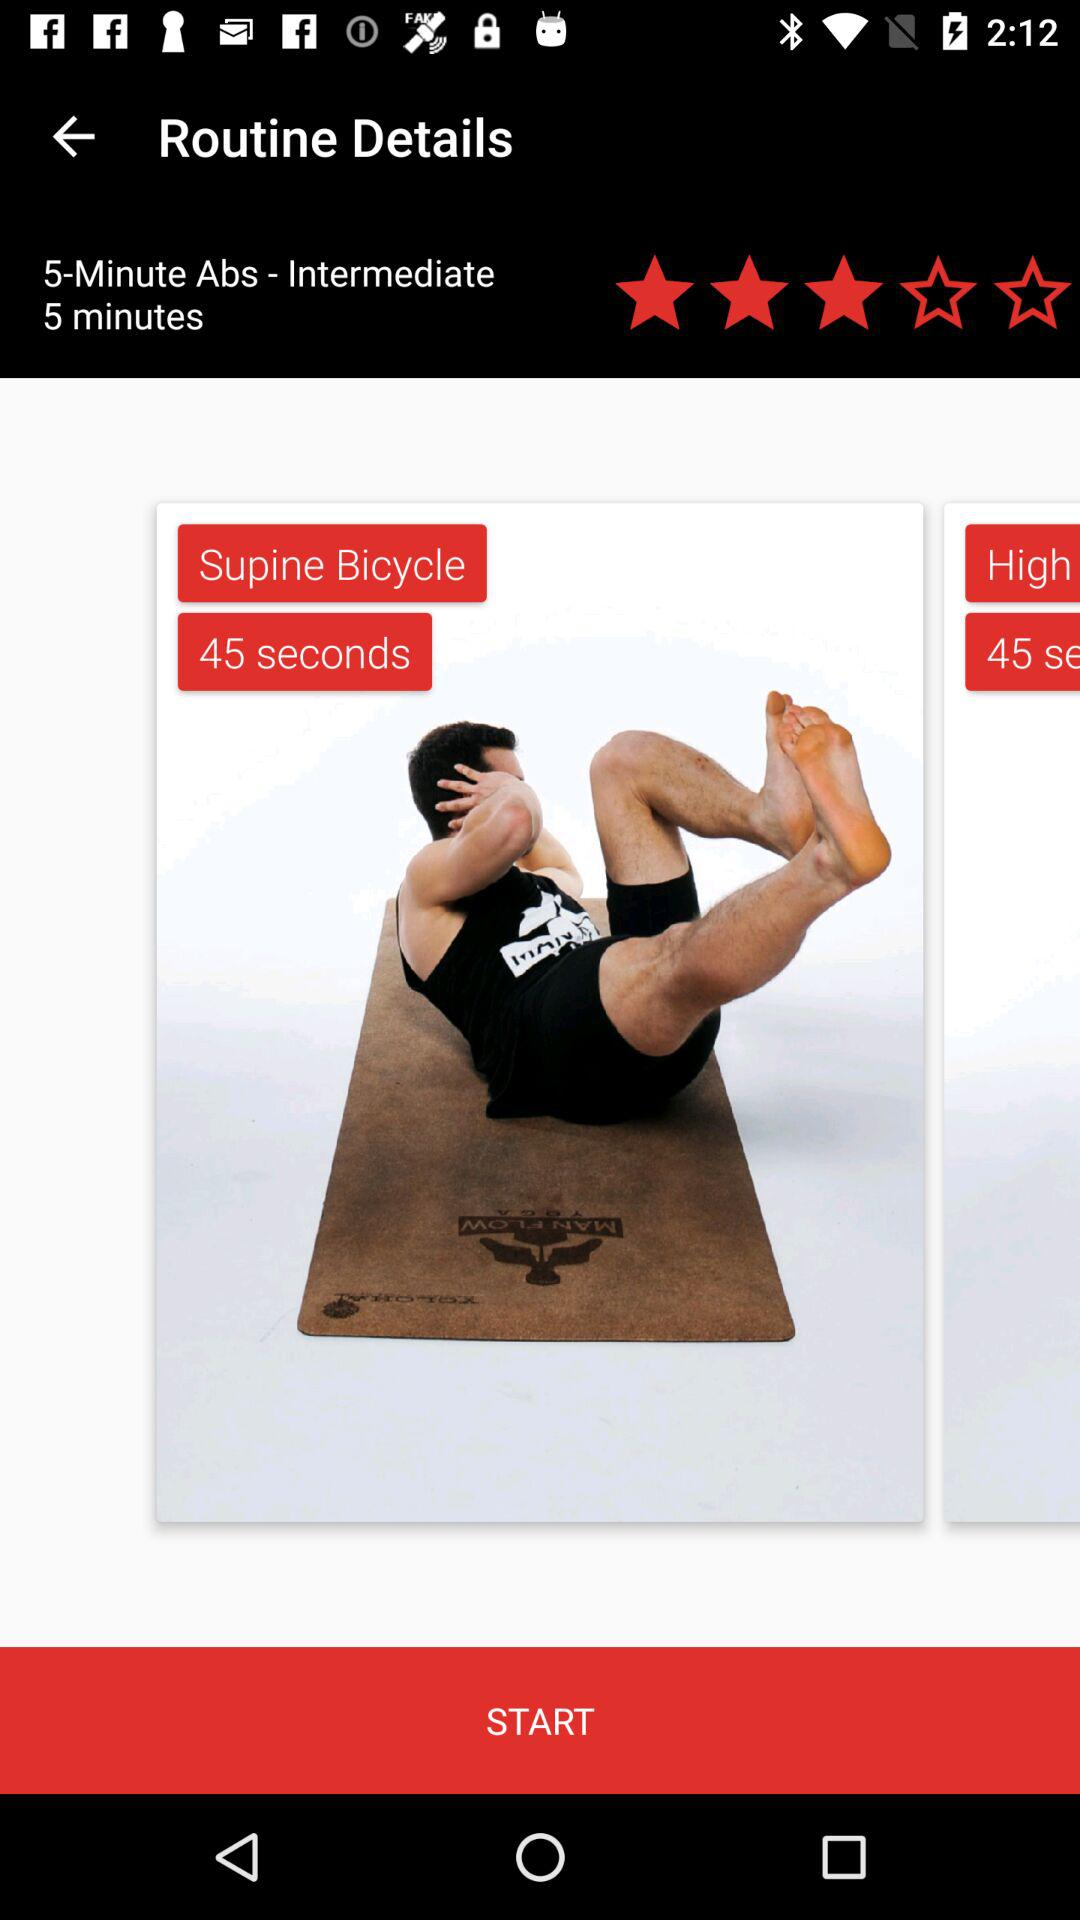What is the time duration for "Abs - Intermediate"? The time duration is 5 minutes. 